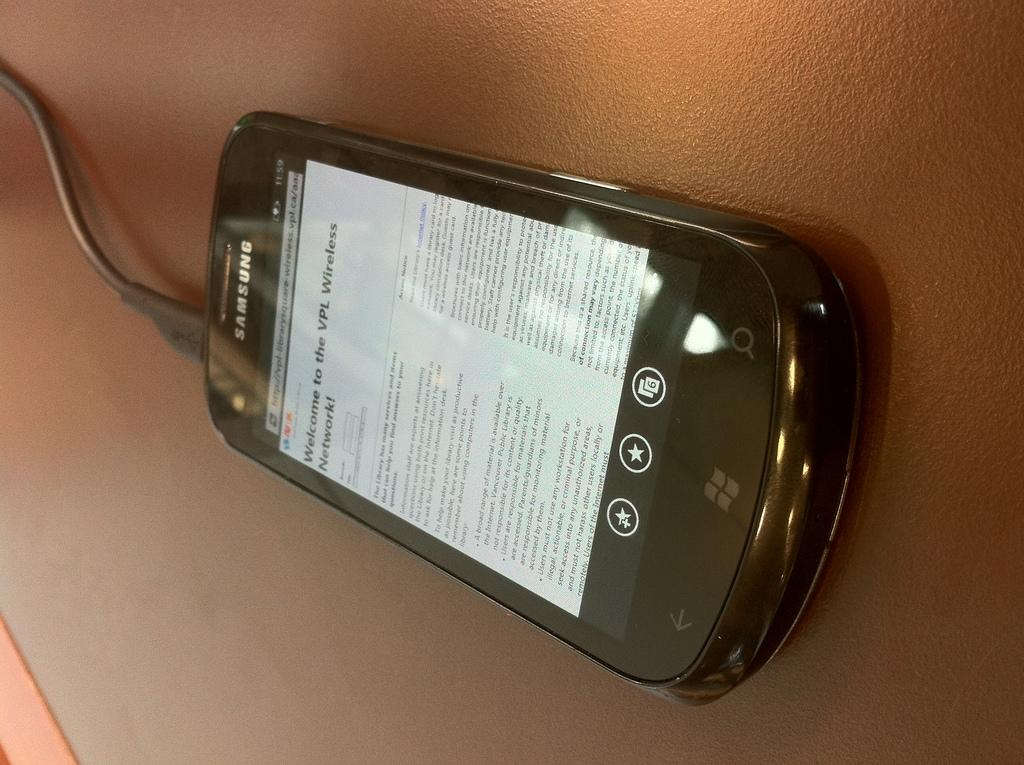<image>
Present a compact description of the photo's key features. A black Samsung phone charging on a leather pad. 